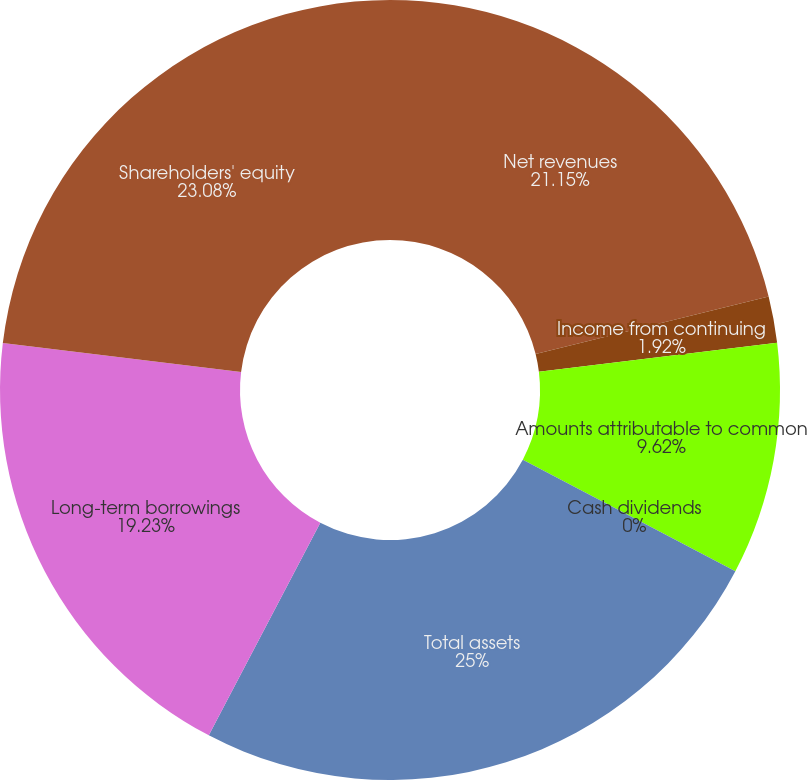<chart> <loc_0><loc_0><loc_500><loc_500><pie_chart><fcel>Net revenues<fcel>Income from continuing<fcel>Amounts attributable to common<fcel>Cash dividends<fcel>Total assets<fcel>Long-term borrowings<fcel>Shareholders' equity<nl><fcel>21.15%<fcel>1.92%<fcel>9.62%<fcel>0.0%<fcel>25.0%<fcel>19.23%<fcel>23.08%<nl></chart> 